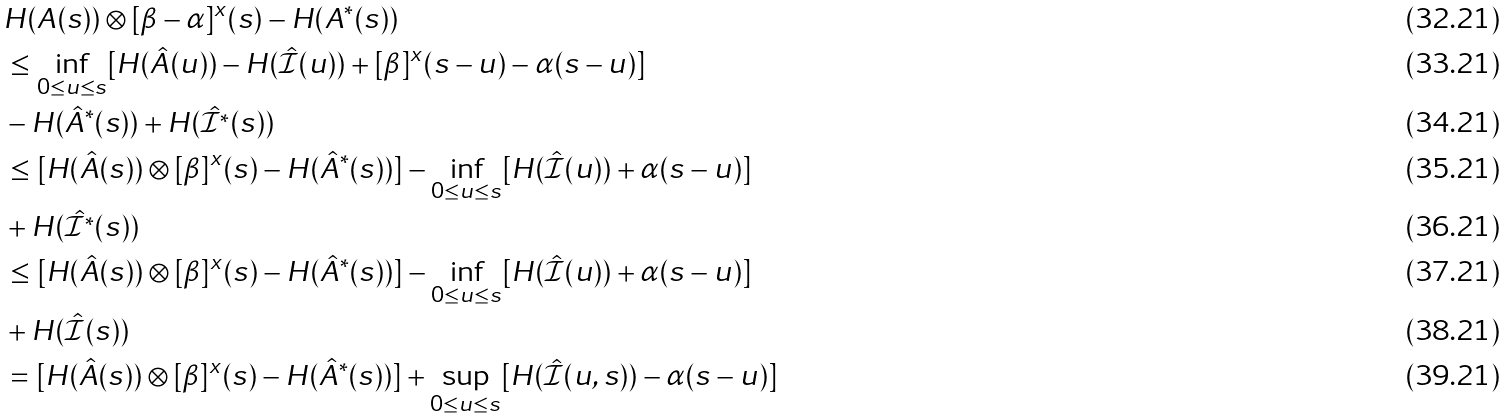<formula> <loc_0><loc_0><loc_500><loc_500>& H ( A ( s ) ) \otimes [ \beta - \alpha ] ^ { x } ( s ) - H ( A ^ { * } ( s ) ) \\ & \leq \inf _ { 0 \leq u \leq s } [ H ( \hat { A } ( u ) ) - H ( \hat { \mathcal { I } } ( u ) ) + [ \beta ] ^ { x } ( s - u ) - \alpha ( s - u ) ] \\ & - H ( \hat { A } ^ { * } ( s ) ) + H ( \hat { \mathcal { I } ^ { * } } ( s ) ) \\ & \leq [ H ( \hat { A } ( s ) ) \otimes [ \beta ] ^ { x } ( s ) - H ( \hat { A } ^ { * } ( s ) ) ] - \inf _ { 0 \leq u \leq s } [ H ( \hat { \mathcal { I } } ( u ) ) + \alpha ( s - u ) ] \\ & + H ( \hat { \mathcal { I } ^ { * } } ( s ) ) \\ & \leq [ H ( \hat { A } ( s ) ) \otimes [ \beta ] ^ { x } ( s ) - H ( \hat { A } ^ { * } ( s ) ) ] - \inf _ { 0 \leq u \leq s } [ H ( \hat { \mathcal { I } } ( u ) ) + \alpha ( s - u ) ] \\ & + H ( \hat { \mathcal { I } } ( s ) ) \\ & = [ H ( \hat { A } ( s ) ) \otimes [ \beta ] ^ { x } ( s ) - H ( \hat { A } ^ { * } ( s ) ) ] + \sup _ { 0 \leq u \leq s } [ H ( \hat { \mathcal { I } } ( u , s ) ) - \alpha ( s - u ) ]</formula> 